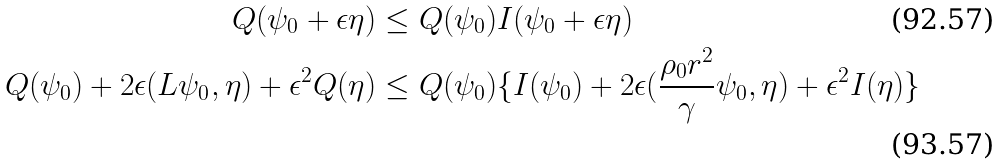Convert formula to latex. <formula><loc_0><loc_0><loc_500><loc_500>Q ( \psi _ { 0 } + \epsilon \eta ) & \leq Q ( \psi _ { 0 } ) I ( \psi _ { 0 } + \epsilon \eta ) \\ Q ( \psi _ { 0 } ) + 2 \epsilon ( L \psi _ { 0 } , \eta ) + \epsilon ^ { 2 } Q ( \eta ) & \leq Q ( \psi _ { 0 } ) \{ I ( \psi _ { 0 } ) + 2 \epsilon ( \frac { \rho _ { 0 } r ^ { 2 } } { \gamma } \psi _ { 0 } , \eta ) + \epsilon ^ { 2 } I ( \eta ) \} \</formula> 